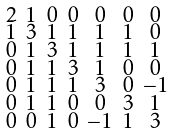Convert formula to latex. <formula><loc_0><loc_0><loc_500><loc_500>\begin{smallmatrix} 2 & 1 & 0 & 0 & 0 & 0 & 0 \\ 1 & 3 & 1 & 1 & 1 & 1 & 0 \\ 0 & 1 & 3 & 1 & 1 & 1 & 1 \\ 0 & 1 & 1 & 3 & 1 & 0 & 0 \\ 0 & 1 & 1 & 1 & 3 & 0 & - 1 \\ 0 & 1 & 1 & 0 & 0 & 3 & 1 \\ 0 & 0 & 1 & 0 & - 1 & 1 & 3 \end{smallmatrix}</formula> 